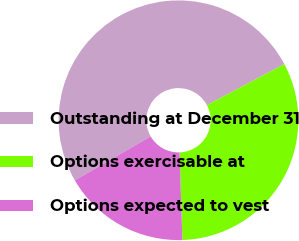<chart> <loc_0><loc_0><loc_500><loc_500><pie_chart><fcel>Outstanding at December 31<fcel>Options exercisable at<fcel>Options expected to vest<nl><fcel>50.6%<fcel>32.24%<fcel>17.16%<nl></chart> 